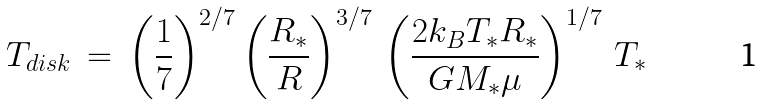Convert formula to latex. <formula><loc_0><loc_0><loc_500><loc_500>T _ { d i s k } \, = \, \left ( \frac { 1 } { 7 } \right ) ^ { 2 / 7 } \left ( \frac { R _ { * } } { R } \right ) ^ { 3 / 7 } \, \left ( \frac { 2 k _ { B } T _ { * } R _ { * } } { G M _ { * } { \mu } } \right ) ^ { 1 / 7 } \, T _ { * }</formula> 